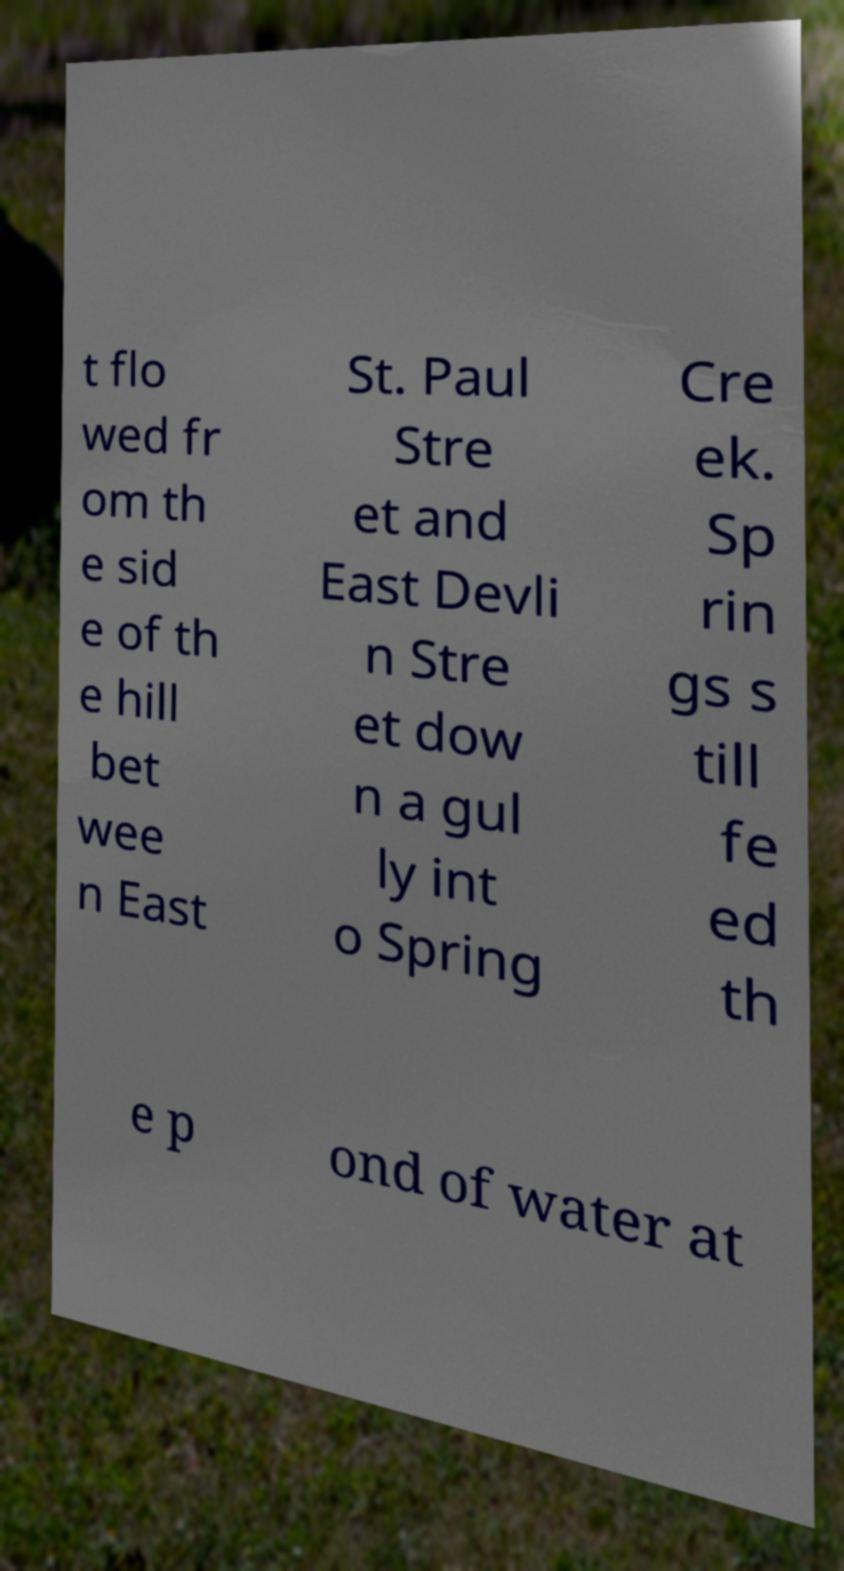Please identify and transcribe the text found in this image. t flo wed fr om th e sid e of th e hill bet wee n East St. Paul Stre et and East Devli n Stre et dow n a gul ly int o Spring Cre ek. Sp rin gs s till fe ed th e p ond of water at 